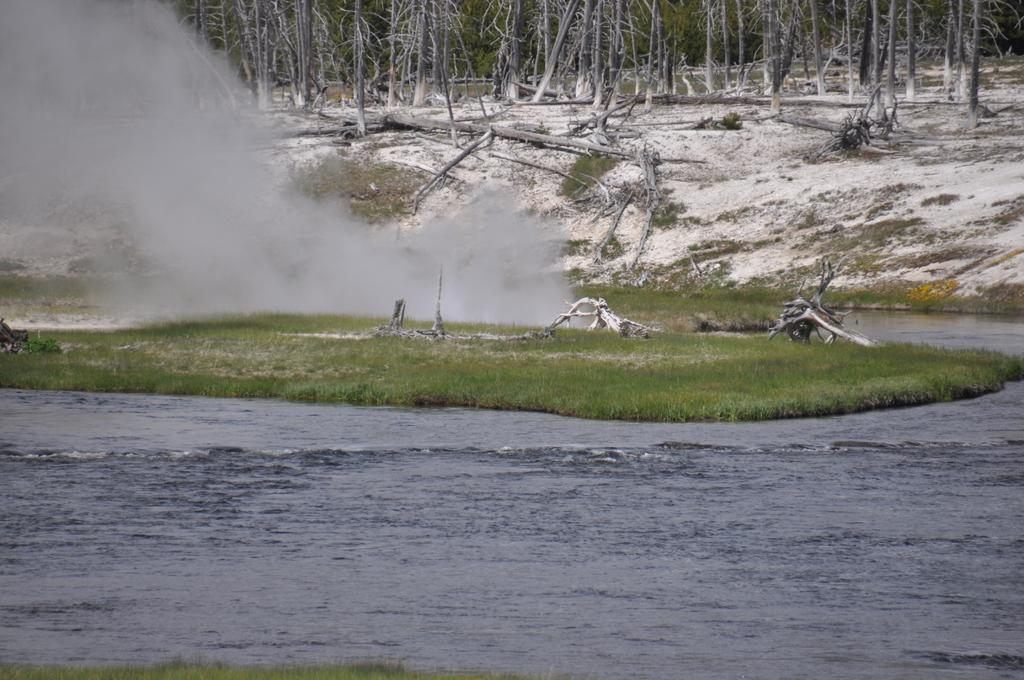What is the primary element visible in the image? There is water in the image. What type of vegetation can be seen in the image? There is grass in the image. What objects are made of wood in the image? There are wooden sticks in the image. What can be seen in the background of the image? There are trees and snow in the background of the image. Can you see a kitten playing with a worm in the image? There is no kitten or worm present in the image. 